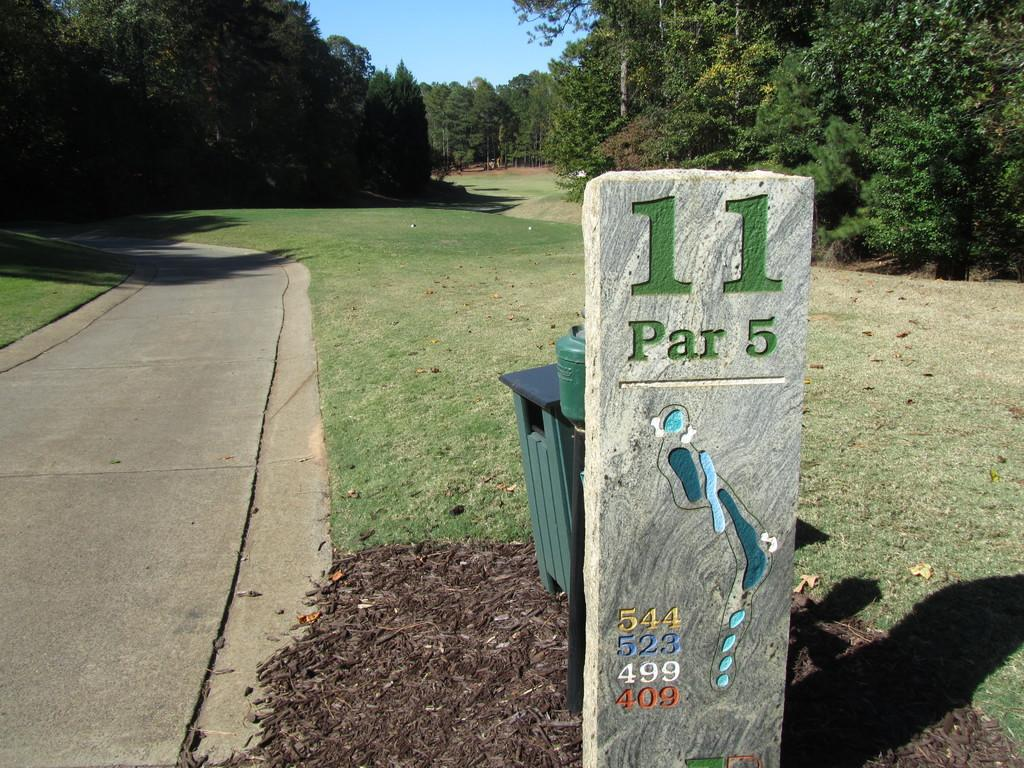<image>
Share a concise interpretation of the image provided. Hole number 11 on this golf course is a par 5. 